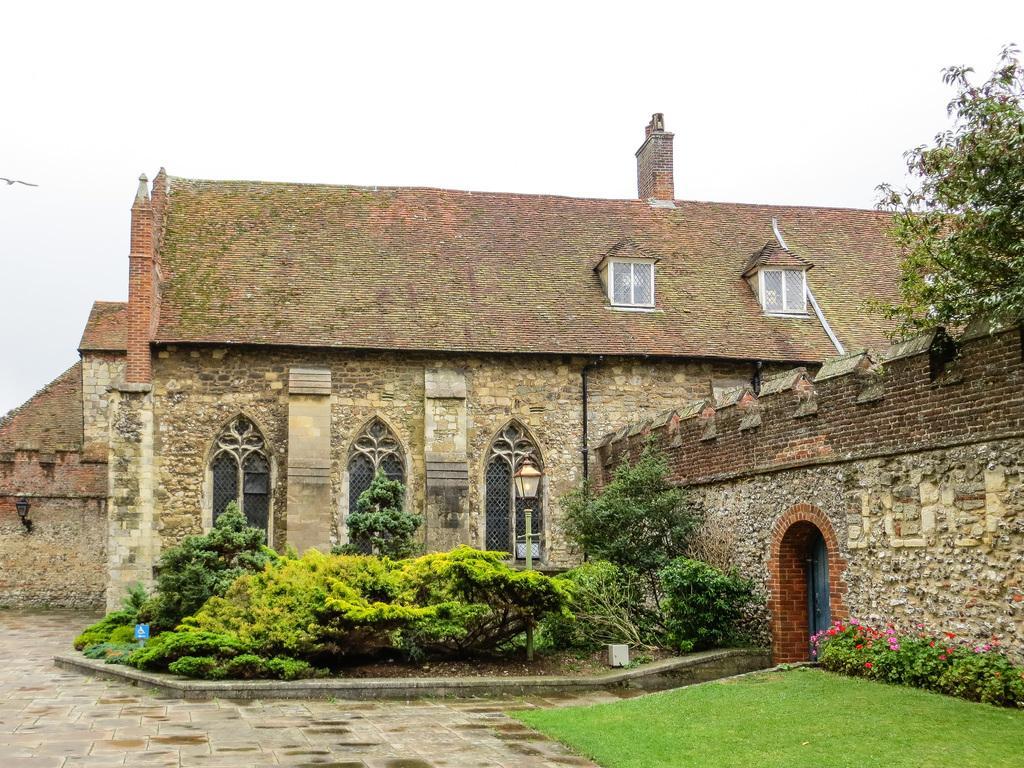Please provide a concise description of this image. In this picture we can see a building with windows, door, trees, grass, flowers and in the background we can see a bird flying in the sky. 